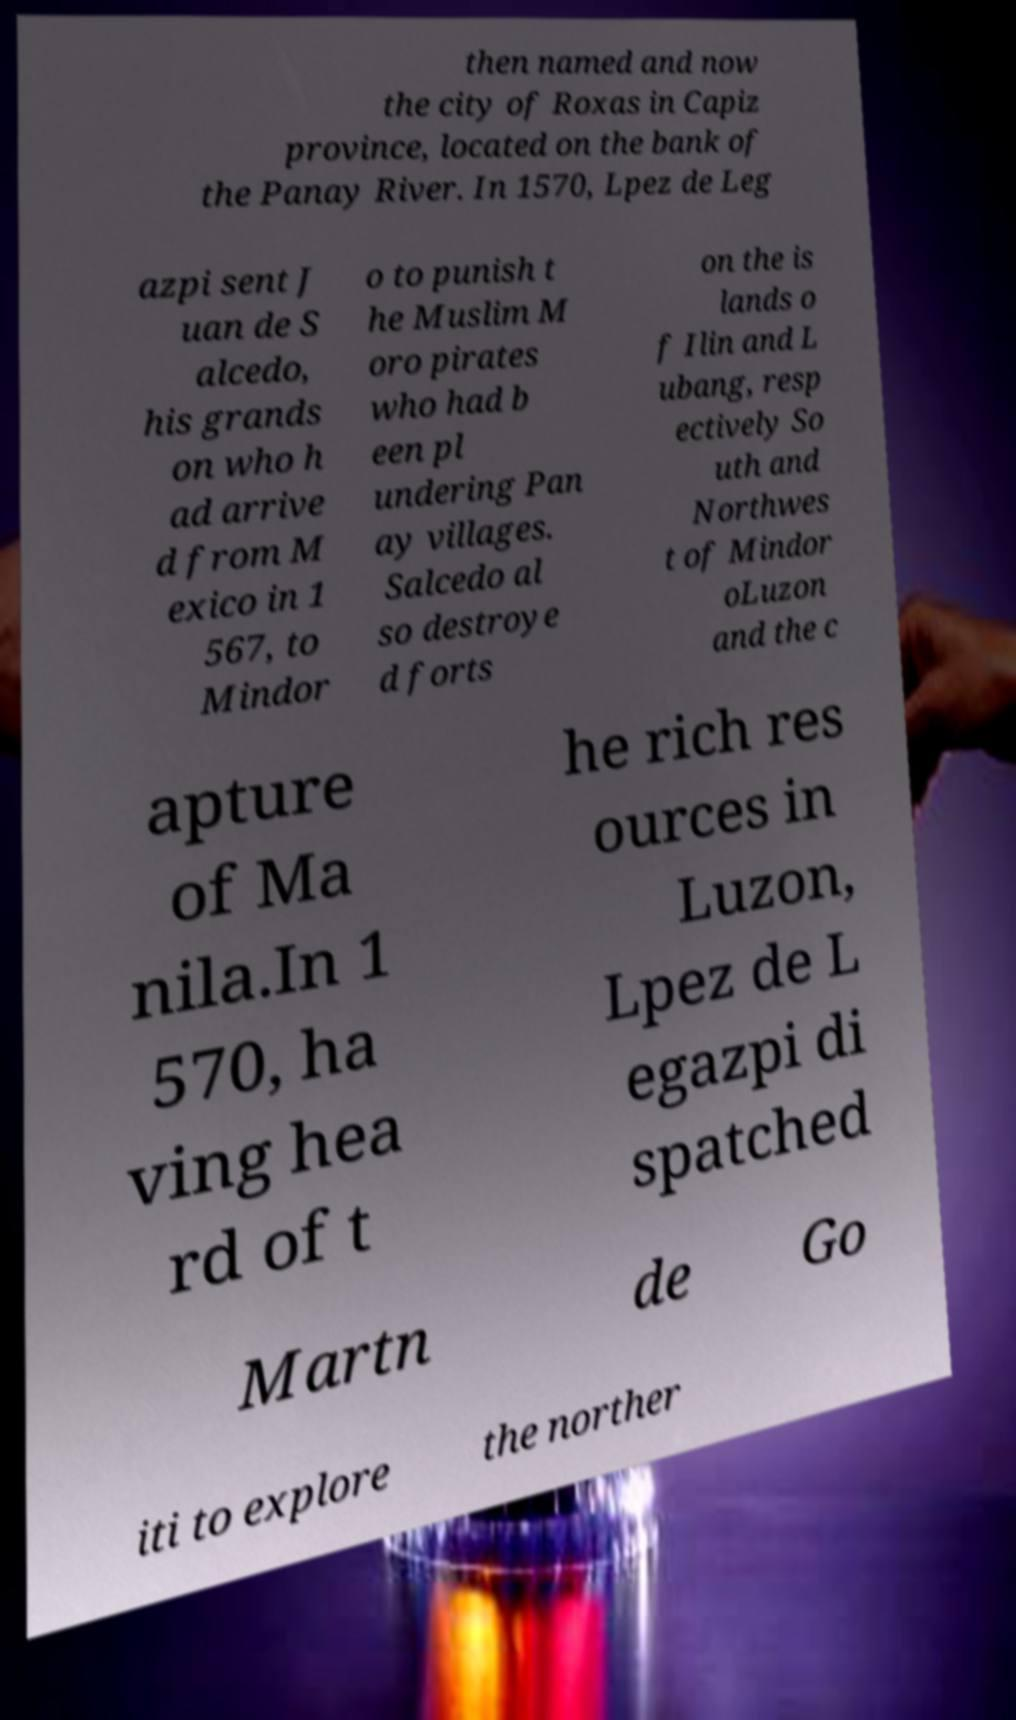Can you accurately transcribe the text from the provided image for me? then named and now the city of Roxas in Capiz province, located on the bank of the Panay River. In 1570, Lpez de Leg azpi sent J uan de S alcedo, his grands on who h ad arrive d from M exico in 1 567, to Mindor o to punish t he Muslim M oro pirates who had b een pl undering Pan ay villages. Salcedo al so destroye d forts on the is lands o f Ilin and L ubang, resp ectively So uth and Northwes t of Mindor oLuzon and the c apture of Ma nila.In 1 570, ha ving hea rd of t he rich res ources in Luzon, Lpez de L egazpi di spatched Martn de Go iti to explore the norther 